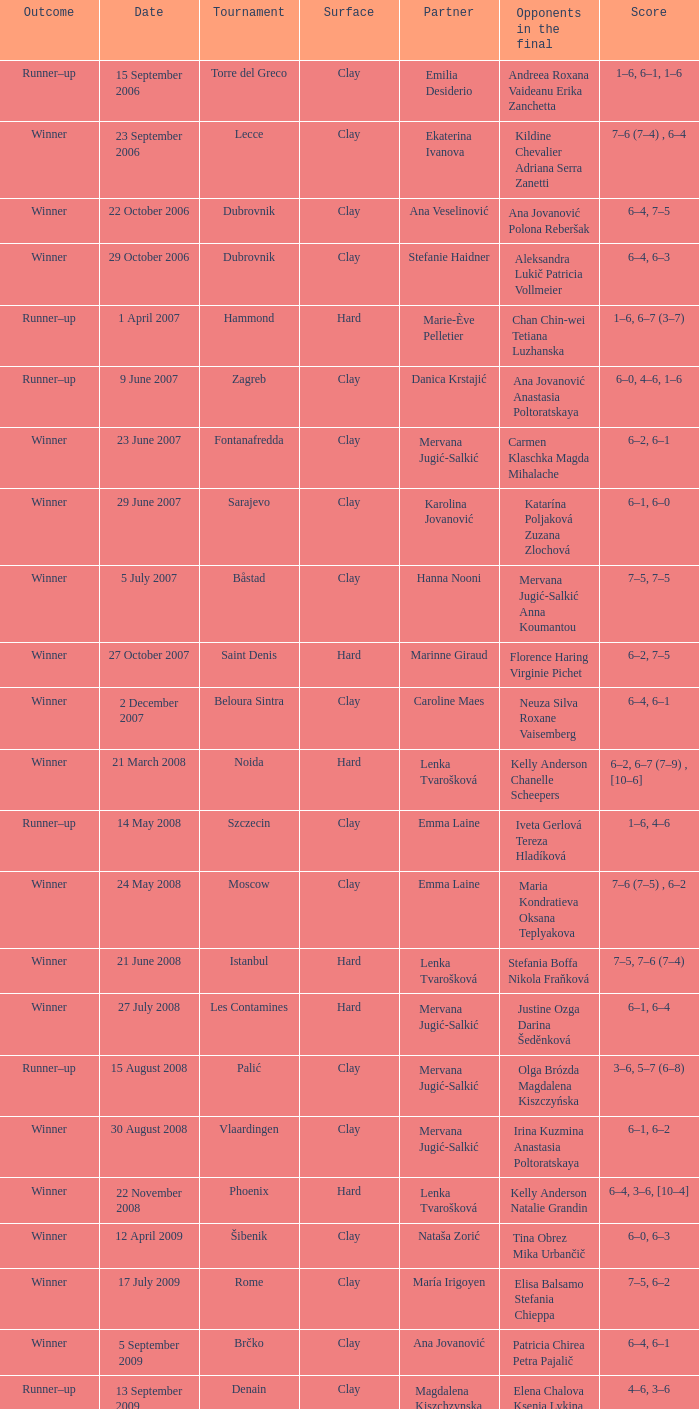In the noida championship match, who faced each other? Kelly Anderson Chanelle Scheepers. 